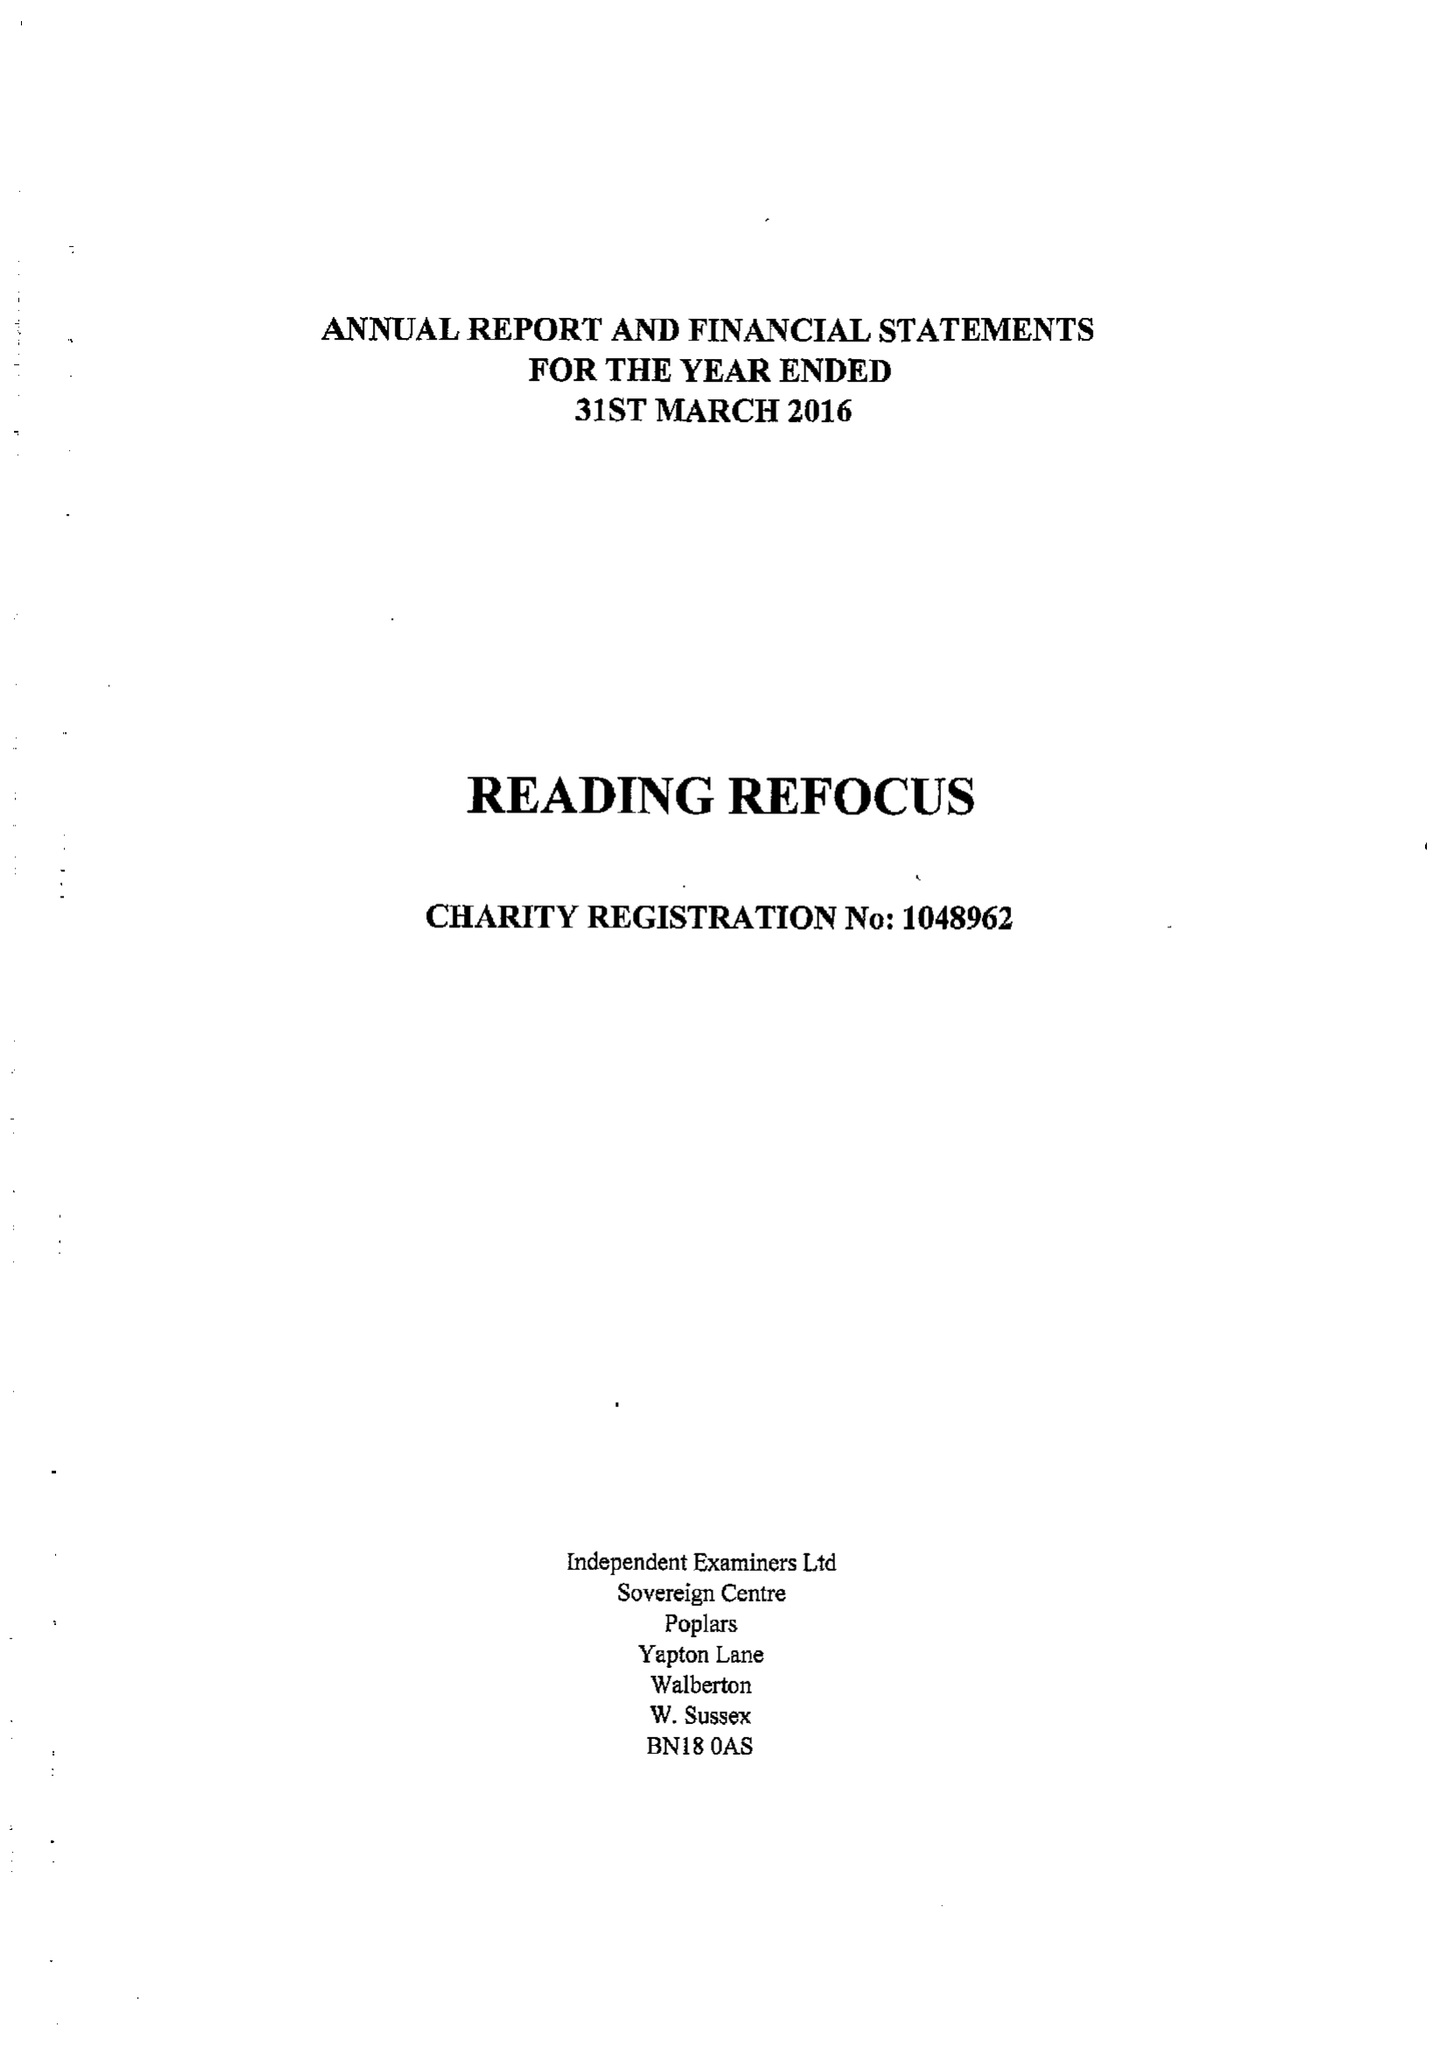What is the value for the report_date?
Answer the question using a single word or phrase. 2016-03-31 